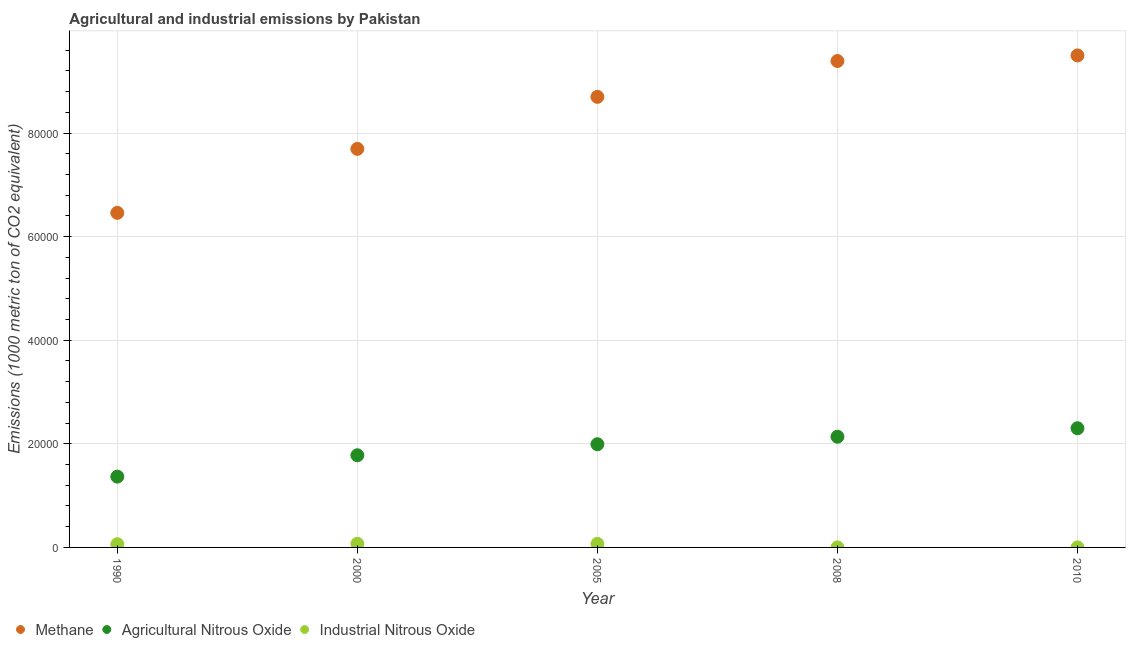Is the number of dotlines equal to the number of legend labels?
Your answer should be very brief. Yes. Across all years, what is the maximum amount of methane emissions?
Provide a short and direct response. 9.50e+04. In which year was the amount of methane emissions maximum?
Make the answer very short. 2010. In which year was the amount of methane emissions minimum?
Make the answer very short. 1990. What is the total amount of agricultural nitrous oxide emissions in the graph?
Keep it short and to the point. 9.58e+04. What is the difference between the amount of industrial nitrous oxide emissions in 2008 and that in 2010?
Offer a very short reply. -0.1. What is the difference between the amount of industrial nitrous oxide emissions in 2010 and the amount of agricultural nitrous oxide emissions in 2000?
Offer a very short reply. -1.78e+04. What is the average amount of methane emissions per year?
Your response must be concise. 8.35e+04. In the year 2000, what is the difference between the amount of agricultural nitrous oxide emissions and amount of industrial nitrous oxide emissions?
Offer a very short reply. 1.71e+04. In how many years, is the amount of industrial nitrous oxide emissions greater than 92000 metric ton?
Your response must be concise. 0. What is the ratio of the amount of agricultural nitrous oxide emissions in 2005 to that in 2010?
Offer a very short reply. 0.87. What is the difference between the highest and the second highest amount of agricultural nitrous oxide emissions?
Keep it short and to the point. 1637.6. What is the difference between the highest and the lowest amount of industrial nitrous oxide emissions?
Offer a very short reply. 699.5. In how many years, is the amount of methane emissions greater than the average amount of methane emissions taken over all years?
Offer a very short reply. 3. Is it the case that in every year, the sum of the amount of methane emissions and amount of agricultural nitrous oxide emissions is greater than the amount of industrial nitrous oxide emissions?
Provide a short and direct response. Yes. Is the amount of industrial nitrous oxide emissions strictly less than the amount of agricultural nitrous oxide emissions over the years?
Make the answer very short. Yes. What is the difference between two consecutive major ticks on the Y-axis?
Your answer should be compact. 2.00e+04. Are the values on the major ticks of Y-axis written in scientific E-notation?
Provide a succinct answer. No. Does the graph contain any zero values?
Keep it short and to the point. No. How many legend labels are there?
Your answer should be compact. 3. How are the legend labels stacked?
Provide a succinct answer. Horizontal. What is the title of the graph?
Give a very brief answer. Agricultural and industrial emissions by Pakistan. Does "Interest" appear as one of the legend labels in the graph?
Ensure brevity in your answer.  No. What is the label or title of the X-axis?
Offer a terse response. Year. What is the label or title of the Y-axis?
Provide a short and direct response. Emissions (1000 metric ton of CO2 equivalent). What is the Emissions (1000 metric ton of CO2 equivalent) of Methane in 1990?
Keep it short and to the point. 6.46e+04. What is the Emissions (1000 metric ton of CO2 equivalent) in Agricultural Nitrous Oxide in 1990?
Your response must be concise. 1.37e+04. What is the Emissions (1000 metric ton of CO2 equivalent) of Industrial Nitrous Oxide in 1990?
Your response must be concise. 625. What is the Emissions (1000 metric ton of CO2 equivalent) of Methane in 2000?
Ensure brevity in your answer.  7.69e+04. What is the Emissions (1000 metric ton of CO2 equivalent) in Agricultural Nitrous Oxide in 2000?
Offer a very short reply. 1.78e+04. What is the Emissions (1000 metric ton of CO2 equivalent) in Industrial Nitrous Oxide in 2000?
Provide a succinct answer. 703.1. What is the Emissions (1000 metric ton of CO2 equivalent) of Methane in 2005?
Your response must be concise. 8.70e+04. What is the Emissions (1000 metric ton of CO2 equivalent) of Agricultural Nitrous Oxide in 2005?
Offer a terse response. 1.99e+04. What is the Emissions (1000 metric ton of CO2 equivalent) of Industrial Nitrous Oxide in 2005?
Ensure brevity in your answer.  682.4. What is the Emissions (1000 metric ton of CO2 equivalent) of Methane in 2008?
Offer a terse response. 9.39e+04. What is the Emissions (1000 metric ton of CO2 equivalent) in Agricultural Nitrous Oxide in 2008?
Make the answer very short. 2.14e+04. What is the Emissions (1000 metric ton of CO2 equivalent) in Industrial Nitrous Oxide in 2008?
Your answer should be very brief. 3.6. What is the Emissions (1000 metric ton of CO2 equivalent) of Methane in 2010?
Give a very brief answer. 9.50e+04. What is the Emissions (1000 metric ton of CO2 equivalent) of Agricultural Nitrous Oxide in 2010?
Give a very brief answer. 2.30e+04. What is the Emissions (1000 metric ton of CO2 equivalent) in Industrial Nitrous Oxide in 2010?
Make the answer very short. 3.7. Across all years, what is the maximum Emissions (1000 metric ton of CO2 equivalent) in Methane?
Provide a succinct answer. 9.50e+04. Across all years, what is the maximum Emissions (1000 metric ton of CO2 equivalent) in Agricultural Nitrous Oxide?
Offer a terse response. 2.30e+04. Across all years, what is the maximum Emissions (1000 metric ton of CO2 equivalent) in Industrial Nitrous Oxide?
Offer a terse response. 703.1. Across all years, what is the minimum Emissions (1000 metric ton of CO2 equivalent) in Methane?
Make the answer very short. 6.46e+04. Across all years, what is the minimum Emissions (1000 metric ton of CO2 equivalent) of Agricultural Nitrous Oxide?
Offer a very short reply. 1.37e+04. What is the total Emissions (1000 metric ton of CO2 equivalent) in Methane in the graph?
Ensure brevity in your answer.  4.17e+05. What is the total Emissions (1000 metric ton of CO2 equivalent) of Agricultural Nitrous Oxide in the graph?
Ensure brevity in your answer.  9.58e+04. What is the total Emissions (1000 metric ton of CO2 equivalent) in Industrial Nitrous Oxide in the graph?
Ensure brevity in your answer.  2017.8. What is the difference between the Emissions (1000 metric ton of CO2 equivalent) of Methane in 1990 and that in 2000?
Provide a short and direct response. -1.24e+04. What is the difference between the Emissions (1000 metric ton of CO2 equivalent) of Agricultural Nitrous Oxide in 1990 and that in 2000?
Give a very brief answer. -4125.3. What is the difference between the Emissions (1000 metric ton of CO2 equivalent) of Industrial Nitrous Oxide in 1990 and that in 2000?
Give a very brief answer. -78.1. What is the difference between the Emissions (1000 metric ton of CO2 equivalent) of Methane in 1990 and that in 2005?
Offer a very short reply. -2.24e+04. What is the difference between the Emissions (1000 metric ton of CO2 equivalent) of Agricultural Nitrous Oxide in 1990 and that in 2005?
Provide a succinct answer. -6255.8. What is the difference between the Emissions (1000 metric ton of CO2 equivalent) of Industrial Nitrous Oxide in 1990 and that in 2005?
Provide a short and direct response. -57.4. What is the difference between the Emissions (1000 metric ton of CO2 equivalent) of Methane in 1990 and that in 2008?
Provide a short and direct response. -2.93e+04. What is the difference between the Emissions (1000 metric ton of CO2 equivalent) of Agricultural Nitrous Oxide in 1990 and that in 2008?
Your answer should be very brief. -7703.6. What is the difference between the Emissions (1000 metric ton of CO2 equivalent) of Industrial Nitrous Oxide in 1990 and that in 2008?
Provide a succinct answer. 621.4. What is the difference between the Emissions (1000 metric ton of CO2 equivalent) in Methane in 1990 and that in 2010?
Your answer should be compact. -3.04e+04. What is the difference between the Emissions (1000 metric ton of CO2 equivalent) of Agricultural Nitrous Oxide in 1990 and that in 2010?
Offer a terse response. -9341.2. What is the difference between the Emissions (1000 metric ton of CO2 equivalent) of Industrial Nitrous Oxide in 1990 and that in 2010?
Keep it short and to the point. 621.3. What is the difference between the Emissions (1000 metric ton of CO2 equivalent) in Methane in 2000 and that in 2005?
Your answer should be compact. -1.00e+04. What is the difference between the Emissions (1000 metric ton of CO2 equivalent) in Agricultural Nitrous Oxide in 2000 and that in 2005?
Ensure brevity in your answer.  -2130.5. What is the difference between the Emissions (1000 metric ton of CO2 equivalent) of Industrial Nitrous Oxide in 2000 and that in 2005?
Keep it short and to the point. 20.7. What is the difference between the Emissions (1000 metric ton of CO2 equivalent) of Methane in 2000 and that in 2008?
Ensure brevity in your answer.  -1.70e+04. What is the difference between the Emissions (1000 metric ton of CO2 equivalent) of Agricultural Nitrous Oxide in 2000 and that in 2008?
Your answer should be compact. -3578.3. What is the difference between the Emissions (1000 metric ton of CO2 equivalent) in Industrial Nitrous Oxide in 2000 and that in 2008?
Make the answer very short. 699.5. What is the difference between the Emissions (1000 metric ton of CO2 equivalent) of Methane in 2000 and that in 2010?
Ensure brevity in your answer.  -1.80e+04. What is the difference between the Emissions (1000 metric ton of CO2 equivalent) in Agricultural Nitrous Oxide in 2000 and that in 2010?
Keep it short and to the point. -5215.9. What is the difference between the Emissions (1000 metric ton of CO2 equivalent) in Industrial Nitrous Oxide in 2000 and that in 2010?
Ensure brevity in your answer.  699.4. What is the difference between the Emissions (1000 metric ton of CO2 equivalent) of Methane in 2005 and that in 2008?
Your response must be concise. -6920.4. What is the difference between the Emissions (1000 metric ton of CO2 equivalent) of Agricultural Nitrous Oxide in 2005 and that in 2008?
Your response must be concise. -1447.8. What is the difference between the Emissions (1000 metric ton of CO2 equivalent) of Industrial Nitrous Oxide in 2005 and that in 2008?
Your answer should be very brief. 678.8. What is the difference between the Emissions (1000 metric ton of CO2 equivalent) in Methane in 2005 and that in 2010?
Your answer should be very brief. -8002.4. What is the difference between the Emissions (1000 metric ton of CO2 equivalent) in Agricultural Nitrous Oxide in 2005 and that in 2010?
Give a very brief answer. -3085.4. What is the difference between the Emissions (1000 metric ton of CO2 equivalent) of Industrial Nitrous Oxide in 2005 and that in 2010?
Offer a very short reply. 678.7. What is the difference between the Emissions (1000 metric ton of CO2 equivalent) of Methane in 2008 and that in 2010?
Give a very brief answer. -1082. What is the difference between the Emissions (1000 metric ton of CO2 equivalent) of Agricultural Nitrous Oxide in 2008 and that in 2010?
Offer a very short reply. -1637.6. What is the difference between the Emissions (1000 metric ton of CO2 equivalent) of Industrial Nitrous Oxide in 2008 and that in 2010?
Offer a very short reply. -0.1. What is the difference between the Emissions (1000 metric ton of CO2 equivalent) in Methane in 1990 and the Emissions (1000 metric ton of CO2 equivalent) in Agricultural Nitrous Oxide in 2000?
Give a very brief answer. 4.68e+04. What is the difference between the Emissions (1000 metric ton of CO2 equivalent) in Methane in 1990 and the Emissions (1000 metric ton of CO2 equivalent) in Industrial Nitrous Oxide in 2000?
Provide a short and direct response. 6.39e+04. What is the difference between the Emissions (1000 metric ton of CO2 equivalent) of Agricultural Nitrous Oxide in 1990 and the Emissions (1000 metric ton of CO2 equivalent) of Industrial Nitrous Oxide in 2000?
Your answer should be very brief. 1.30e+04. What is the difference between the Emissions (1000 metric ton of CO2 equivalent) in Methane in 1990 and the Emissions (1000 metric ton of CO2 equivalent) in Agricultural Nitrous Oxide in 2005?
Offer a terse response. 4.47e+04. What is the difference between the Emissions (1000 metric ton of CO2 equivalent) of Methane in 1990 and the Emissions (1000 metric ton of CO2 equivalent) of Industrial Nitrous Oxide in 2005?
Provide a short and direct response. 6.39e+04. What is the difference between the Emissions (1000 metric ton of CO2 equivalent) in Agricultural Nitrous Oxide in 1990 and the Emissions (1000 metric ton of CO2 equivalent) in Industrial Nitrous Oxide in 2005?
Make the answer very short. 1.30e+04. What is the difference between the Emissions (1000 metric ton of CO2 equivalent) of Methane in 1990 and the Emissions (1000 metric ton of CO2 equivalent) of Agricultural Nitrous Oxide in 2008?
Keep it short and to the point. 4.32e+04. What is the difference between the Emissions (1000 metric ton of CO2 equivalent) of Methane in 1990 and the Emissions (1000 metric ton of CO2 equivalent) of Industrial Nitrous Oxide in 2008?
Your response must be concise. 6.46e+04. What is the difference between the Emissions (1000 metric ton of CO2 equivalent) in Agricultural Nitrous Oxide in 1990 and the Emissions (1000 metric ton of CO2 equivalent) in Industrial Nitrous Oxide in 2008?
Your response must be concise. 1.37e+04. What is the difference between the Emissions (1000 metric ton of CO2 equivalent) in Methane in 1990 and the Emissions (1000 metric ton of CO2 equivalent) in Agricultural Nitrous Oxide in 2010?
Offer a terse response. 4.16e+04. What is the difference between the Emissions (1000 metric ton of CO2 equivalent) of Methane in 1990 and the Emissions (1000 metric ton of CO2 equivalent) of Industrial Nitrous Oxide in 2010?
Ensure brevity in your answer.  6.46e+04. What is the difference between the Emissions (1000 metric ton of CO2 equivalent) in Agricultural Nitrous Oxide in 1990 and the Emissions (1000 metric ton of CO2 equivalent) in Industrial Nitrous Oxide in 2010?
Offer a terse response. 1.37e+04. What is the difference between the Emissions (1000 metric ton of CO2 equivalent) of Methane in 2000 and the Emissions (1000 metric ton of CO2 equivalent) of Agricultural Nitrous Oxide in 2005?
Make the answer very short. 5.70e+04. What is the difference between the Emissions (1000 metric ton of CO2 equivalent) in Methane in 2000 and the Emissions (1000 metric ton of CO2 equivalent) in Industrial Nitrous Oxide in 2005?
Make the answer very short. 7.63e+04. What is the difference between the Emissions (1000 metric ton of CO2 equivalent) of Agricultural Nitrous Oxide in 2000 and the Emissions (1000 metric ton of CO2 equivalent) of Industrial Nitrous Oxide in 2005?
Offer a very short reply. 1.71e+04. What is the difference between the Emissions (1000 metric ton of CO2 equivalent) in Methane in 2000 and the Emissions (1000 metric ton of CO2 equivalent) in Agricultural Nitrous Oxide in 2008?
Ensure brevity in your answer.  5.56e+04. What is the difference between the Emissions (1000 metric ton of CO2 equivalent) of Methane in 2000 and the Emissions (1000 metric ton of CO2 equivalent) of Industrial Nitrous Oxide in 2008?
Your response must be concise. 7.69e+04. What is the difference between the Emissions (1000 metric ton of CO2 equivalent) in Agricultural Nitrous Oxide in 2000 and the Emissions (1000 metric ton of CO2 equivalent) in Industrial Nitrous Oxide in 2008?
Provide a succinct answer. 1.78e+04. What is the difference between the Emissions (1000 metric ton of CO2 equivalent) in Methane in 2000 and the Emissions (1000 metric ton of CO2 equivalent) in Agricultural Nitrous Oxide in 2010?
Ensure brevity in your answer.  5.39e+04. What is the difference between the Emissions (1000 metric ton of CO2 equivalent) in Methane in 2000 and the Emissions (1000 metric ton of CO2 equivalent) in Industrial Nitrous Oxide in 2010?
Make the answer very short. 7.69e+04. What is the difference between the Emissions (1000 metric ton of CO2 equivalent) of Agricultural Nitrous Oxide in 2000 and the Emissions (1000 metric ton of CO2 equivalent) of Industrial Nitrous Oxide in 2010?
Ensure brevity in your answer.  1.78e+04. What is the difference between the Emissions (1000 metric ton of CO2 equivalent) of Methane in 2005 and the Emissions (1000 metric ton of CO2 equivalent) of Agricultural Nitrous Oxide in 2008?
Keep it short and to the point. 6.56e+04. What is the difference between the Emissions (1000 metric ton of CO2 equivalent) in Methane in 2005 and the Emissions (1000 metric ton of CO2 equivalent) in Industrial Nitrous Oxide in 2008?
Offer a terse response. 8.70e+04. What is the difference between the Emissions (1000 metric ton of CO2 equivalent) of Agricultural Nitrous Oxide in 2005 and the Emissions (1000 metric ton of CO2 equivalent) of Industrial Nitrous Oxide in 2008?
Provide a succinct answer. 1.99e+04. What is the difference between the Emissions (1000 metric ton of CO2 equivalent) of Methane in 2005 and the Emissions (1000 metric ton of CO2 equivalent) of Agricultural Nitrous Oxide in 2010?
Offer a very short reply. 6.40e+04. What is the difference between the Emissions (1000 metric ton of CO2 equivalent) of Methane in 2005 and the Emissions (1000 metric ton of CO2 equivalent) of Industrial Nitrous Oxide in 2010?
Keep it short and to the point. 8.70e+04. What is the difference between the Emissions (1000 metric ton of CO2 equivalent) in Agricultural Nitrous Oxide in 2005 and the Emissions (1000 metric ton of CO2 equivalent) in Industrial Nitrous Oxide in 2010?
Your answer should be very brief. 1.99e+04. What is the difference between the Emissions (1000 metric ton of CO2 equivalent) in Methane in 2008 and the Emissions (1000 metric ton of CO2 equivalent) in Agricultural Nitrous Oxide in 2010?
Provide a succinct answer. 7.09e+04. What is the difference between the Emissions (1000 metric ton of CO2 equivalent) in Methane in 2008 and the Emissions (1000 metric ton of CO2 equivalent) in Industrial Nitrous Oxide in 2010?
Make the answer very short. 9.39e+04. What is the difference between the Emissions (1000 metric ton of CO2 equivalent) of Agricultural Nitrous Oxide in 2008 and the Emissions (1000 metric ton of CO2 equivalent) of Industrial Nitrous Oxide in 2010?
Your answer should be very brief. 2.14e+04. What is the average Emissions (1000 metric ton of CO2 equivalent) of Methane per year?
Provide a succinct answer. 8.35e+04. What is the average Emissions (1000 metric ton of CO2 equivalent) in Agricultural Nitrous Oxide per year?
Give a very brief answer. 1.92e+04. What is the average Emissions (1000 metric ton of CO2 equivalent) in Industrial Nitrous Oxide per year?
Your response must be concise. 403.56. In the year 1990, what is the difference between the Emissions (1000 metric ton of CO2 equivalent) of Methane and Emissions (1000 metric ton of CO2 equivalent) of Agricultural Nitrous Oxide?
Offer a terse response. 5.09e+04. In the year 1990, what is the difference between the Emissions (1000 metric ton of CO2 equivalent) of Methane and Emissions (1000 metric ton of CO2 equivalent) of Industrial Nitrous Oxide?
Give a very brief answer. 6.40e+04. In the year 1990, what is the difference between the Emissions (1000 metric ton of CO2 equivalent) in Agricultural Nitrous Oxide and Emissions (1000 metric ton of CO2 equivalent) in Industrial Nitrous Oxide?
Your answer should be very brief. 1.30e+04. In the year 2000, what is the difference between the Emissions (1000 metric ton of CO2 equivalent) of Methane and Emissions (1000 metric ton of CO2 equivalent) of Agricultural Nitrous Oxide?
Offer a very short reply. 5.92e+04. In the year 2000, what is the difference between the Emissions (1000 metric ton of CO2 equivalent) in Methane and Emissions (1000 metric ton of CO2 equivalent) in Industrial Nitrous Oxide?
Your answer should be very brief. 7.62e+04. In the year 2000, what is the difference between the Emissions (1000 metric ton of CO2 equivalent) in Agricultural Nitrous Oxide and Emissions (1000 metric ton of CO2 equivalent) in Industrial Nitrous Oxide?
Provide a succinct answer. 1.71e+04. In the year 2005, what is the difference between the Emissions (1000 metric ton of CO2 equivalent) of Methane and Emissions (1000 metric ton of CO2 equivalent) of Agricultural Nitrous Oxide?
Make the answer very short. 6.71e+04. In the year 2005, what is the difference between the Emissions (1000 metric ton of CO2 equivalent) of Methane and Emissions (1000 metric ton of CO2 equivalent) of Industrial Nitrous Oxide?
Give a very brief answer. 8.63e+04. In the year 2005, what is the difference between the Emissions (1000 metric ton of CO2 equivalent) of Agricultural Nitrous Oxide and Emissions (1000 metric ton of CO2 equivalent) of Industrial Nitrous Oxide?
Your answer should be compact. 1.92e+04. In the year 2008, what is the difference between the Emissions (1000 metric ton of CO2 equivalent) in Methane and Emissions (1000 metric ton of CO2 equivalent) in Agricultural Nitrous Oxide?
Give a very brief answer. 7.25e+04. In the year 2008, what is the difference between the Emissions (1000 metric ton of CO2 equivalent) of Methane and Emissions (1000 metric ton of CO2 equivalent) of Industrial Nitrous Oxide?
Make the answer very short. 9.39e+04. In the year 2008, what is the difference between the Emissions (1000 metric ton of CO2 equivalent) in Agricultural Nitrous Oxide and Emissions (1000 metric ton of CO2 equivalent) in Industrial Nitrous Oxide?
Offer a very short reply. 2.14e+04. In the year 2010, what is the difference between the Emissions (1000 metric ton of CO2 equivalent) of Methane and Emissions (1000 metric ton of CO2 equivalent) of Agricultural Nitrous Oxide?
Offer a terse response. 7.20e+04. In the year 2010, what is the difference between the Emissions (1000 metric ton of CO2 equivalent) in Methane and Emissions (1000 metric ton of CO2 equivalent) in Industrial Nitrous Oxide?
Ensure brevity in your answer.  9.50e+04. In the year 2010, what is the difference between the Emissions (1000 metric ton of CO2 equivalent) in Agricultural Nitrous Oxide and Emissions (1000 metric ton of CO2 equivalent) in Industrial Nitrous Oxide?
Your response must be concise. 2.30e+04. What is the ratio of the Emissions (1000 metric ton of CO2 equivalent) in Methane in 1990 to that in 2000?
Give a very brief answer. 0.84. What is the ratio of the Emissions (1000 metric ton of CO2 equivalent) in Agricultural Nitrous Oxide in 1990 to that in 2000?
Provide a succinct answer. 0.77. What is the ratio of the Emissions (1000 metric ton of CO2 equivalent) of Methane in 1990 to that in 2005?
Give a very brief answer. 0.74. What is the ratio of the Emissions (1000 metric ton of CO2 equivalent) of Agricultural Nitrous Oxide in 1990 to that in 2005?
Provide a succinct answer. 0.69. What is the ratio of the Emissions (1000 metric ton of CO2 equivalent) of Industrial Nitrous Oxide in 1990 to that in 2005?
Make the answer very short. 0.92. What is the ratio of the Emissions (1000 metric ton of CO2 equivalent) of Methane in 1990 to that in 2008?
Provide a succinct answer. 0.69. What is the ratio of the Emissions (1000 metric ton of CO2 equivalent) in Agricultural Nitrous Oxide in 1990 to that in 2008?
Your answer should be compact. 0.64. What is the ratio of the Emissions (1000 metric ton of CO2 equivalent) in Industrial Nitrous Oxide in 1990 to that in 2008?
Give a very brief answer. 173.61. What is the ratio of the Emissions (1000 metric ton of CO2 equivalent) of Methane in 1990 to that in 2010?
Make the answer very short. 0.68. What is the ratio of the Emissions (1000 metric ton of CO2 equivalent) in Agricultural Nitrous Oxide in 1990 to that in 2010?
Provide a succinct answer. 0.59. What is the ratio of the Emissions (1000 metric ton of CO2 equivalent) of Industrial Nitrous Oxide in 1990 to that in 2010?
Ensure brevity in your answer.  168.92. What is the ratio of the Emissions (1000 metric ton of CO2 equivalent) in Methane in 2000 to that in 2005?
Provide a succinct answer. 0.88. What is the ratio of the Emissions (1000 metric ton of CO2 equivalent) of Agricultural Nitrous Oxide in 2000 to that in 2005?
Provide a short and direct response. 0.89. What is the ratio of the Emissions (1000 metric ton of CO2 equivalent) in Industrial Nitrous Oxide in 2000 to that in 2005?
Make the answer very short. 1.03. What is the ratio of the Emissions (1000 metric ton of CO2 equivalent) in Methane in 2000 to that in 2008?
Offer a terse response. 0.82. What is the ratio of the Emissions (1000 metric ton of CO2 equivalent) of Agricultural Nitrous Oxide in 2000 to that in 2008?
Your answer should be compact. 0.83. What is the ratio of the Emissions (1000 metric ton of CO2 equivalent) in Industrial Nitrous Oxide in 2000 to that in 2008?
Your answer should be very brief. 195.31. What is the ratio of the Emissions (1000 metric ton of CO2 equivalent) of Methane in 2000 to that in 2010?
Your response must be concise. 0.81. What is the ratio of the Emissions (1000 metric ton of CO2 equivalent) of Agricultural Nitrous Oxide in 2000 to that in 2010?
Make the answer very short. 0.77. What is the ratio of the Emissions (1000 metric ton of CO2 equivalent) of Industrial Nitrous Oxide in 2000 to that in 2010?
Your response must be concise. 190.03. What is the ratio of the Emissions (1000 metric ton of CO2 equivalent) of Methane in 2005 to that in 2008?
Your answer should be very brief. 0.93. What is the ratio of the Emissions (1000 metric ton of CO2 equivalent) in Agricultural Nitrous Oxide in 2005 to that in 2008?
Provide a succinct answer. 0.93. What is the ratio of the Emissions (1000 metric ton of CO2 equivalent) of Industrial Nitrous Oxide in 2005 to that in 2008?
Offer a very short reply. 189.56. What is the ratio of the Emissions (1000 metric ton of CO2 equivalent) in Methane in 2005 to that in 2010?
Provide a succinct answer. 0.92. What is the ratio of the Emissions (1000 metric ton of CO2 equivalent) of Agricultural Nitrous Oxide in 2005 to that in 2010?
Offer a very short reply. 0.87. What is the ratio of the Emissions (1000 metric ton of CO2 equivalent) in Industrial Nitrous Oxide in 2005 to that in 2010?
Provide a succinct answer. 184.43. What is the ratio of the Emissions (1000 metric ton of CO2 equivalent) in Agricultural Nitrous Oxide in 2008 to that in 2010?
Provide a short and direct response. 0.93. What is the difference between the highest and the second highest Emissions (1000 metric ton of CO2 equivalent) of Methane?
Your response must be concise. 1082. What is the difference between the highest and the second highest Emissions (1000 metric ton of CO2 equivalent) in Agricultural Nitrous Oxide?
Make the answer very short. 1637.6. What is the difference between the highest and the second highest Emissions (1000 metric ton of CO2 equivalent) in Industrial Nitrous Oxide?
Make the answer very short. 20.7. What is the difference between the highest and the lowest Emissions (1000 metric ton of CO2 equivalent) of Methane?
Provide a short and direct response. 3.04e+04. What is the difference between the highest and the lowest Emissions (1000 metric ton of CO2 equivalent) in Agricultural Nitrous Oxide?
Keep it short and to the point. 9341.2. What is the difference between the highest and the lowest Emissions (1000 metric ton of CO2 equivalent) of Industrial Nitrous Oxide?
Provide a short and direct response. 699.5. 